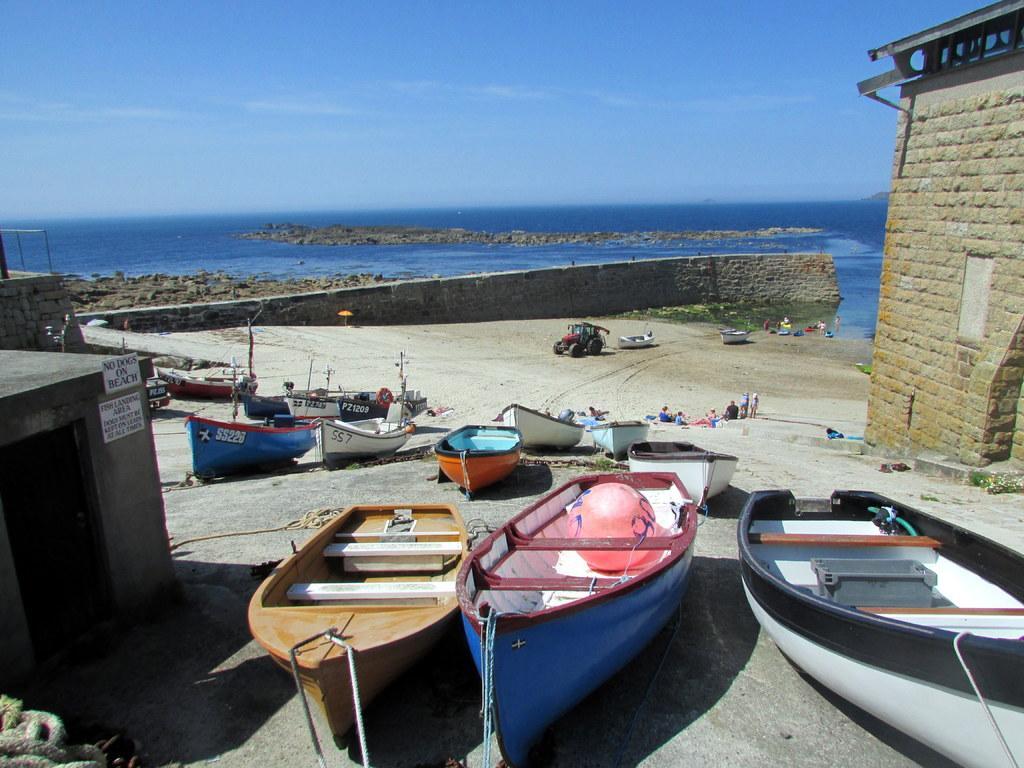Please provide a concise description of this image. In this image we can see many boats on the land. There are few people. On the left side there is a room with a door. On the room there are posters. On the right side there is a brick wall. In the back there is a wall. Also there is water. Also there are rocks. In the background there is sky with clouds. 